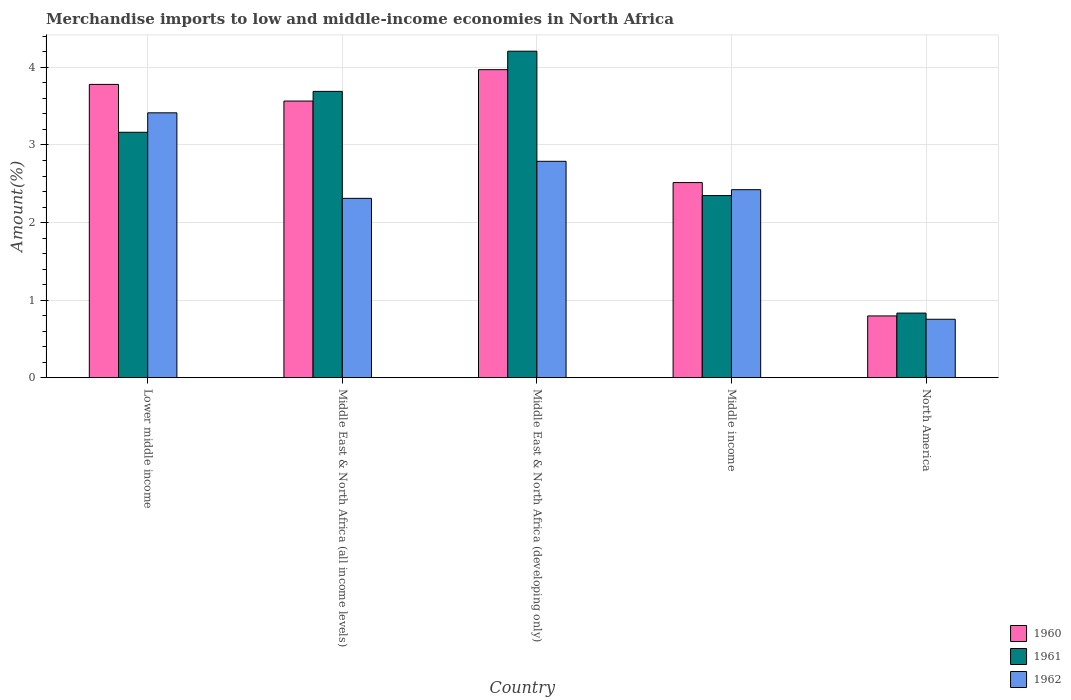How many different coloured bars are there?
Offer a very short reply. 3. How many groups of bars are there?
Your response must be concise. 5. What is the label of the 4th group of bars from the left?
Make the answer very short. Middle income. What is the percentage of amount earned from merchandise imports in 1960 in Middle East & North Africa (developing only)?
Provide a succinct answer. 3.97. Across all countries, what is the maximum percentage of amount earned from merchandise imports in 1962?
Ensure brevity in your answer.  3.41. Across all countries, what is the minimum percentage of amount earned from merchandise imports in 1961?
Make the answer very short. 0.83. In which country was the percentage of amount earned from merchandise imports in 1961 maximum?
Offer a very short reply. Middle East & North Africa (developing only). What is the total percentage of amount earned from merchandise imports in 1960 in the graph?
Your answer should be compact. 14.63. What is the difference between the percentage of amount earned from merchandise imports in 1961 in Lower middle income and that in North America?
Your answer should be very brief. 2.33. What is the difference between the percentage of amount earned from merchandise imports in 1961 in Middle income and the percentage of amount earned from merchandise imports in 1962 in Lower middle income?
Your response must be concise. -1.07. What is the average percentage of amount earned from merchandise imports in 1961 per country?
Keep it short and to the point. 2.85. What is the difference between the percentage of amount earned from merchandise imports of/in 1962 and percentage of amount earned from merchandise imports of/in 1961 in Middle East & North Africa (all income levels)?
Offer a terse response. -1.38. What is the ratio of the percentage of amount earned from merchandise imports in 1962 in Middle East & North Africa (developing only) to that in North America?
Keep it short and to the point. 3.7. Is the percentage of amount earned from merchandise imports in 1960 in Lower middle income less than that in Middle income?
Provide a succinct answer. No. What is the difference between the highest and the second highest percentage of amount earned from merchandise imports in 1961?
Offer a very short reply. -0.53. What is the difference between the highest and the lowest percentage of amount earned from merchandise imports in 1961?
Your response must be concise. 3.38. In how many countries, is the percentage of amount earned from merchandise imports in 1961 greater than the average percentage of amount earned from merchandise imports in 1961 taken over all countries?
Your response must be concise. 3. What does the 2nd bar from the right in North America represents?
Give a very brief answer. 1961. What is the difference between two consecutive major ticks on the Y-axis?
Give a very brief answer. 1. Does the graph contain any zero values?
Your response must be concise. No. How are the legend labels stacked?
Offer a very short reply. Vertical. What is the title of the graph?
Your answer should be very brief. Merchandise imports to low and middle-income economies in North Africa. Does "1962" appear as one of the legend labels in the graph?
Keep it short and to the point. Yes. What is the label or title of the Y-axis?
Make the answer very short. Amount(%). What is the Amount(%) of 1960 in Lower middle income?
Your answer should be very brief. 3.78. What is the Amount(%) of 1961 in Lower middle income?
Your answer should be very brief. 3.16. What is the Amount(%) of 1962 in Lower middle income?
Offer a very short reply. 3.41. What is the Amount(%) in 1960 in Middle East & North Africa (all income levels)?
Your answer should be very brief. 3.57. What is the Amount(%) of 1961 in Middle East & North Africa (all income levels)?
Give a very brief answer. 3.69. What is the Amount(%) of 1962 in Middle East & North Africa (all income levels)?
Give a very brief answer. 2.31. What is the Amount(%) in 1960 in Middle East & North Africa (developing only)?
Ensure brevity in your answer.  3.97. What is the Amount(%) of 1961 in Middle East & North Africa (developing only)?
Your response must be concise. 4.21. What is the Amount(%) in 1962 in Middle East & North Africa (developing only)?
Make the answer very short. 2.79. What is the Amount(%) in 1960 in Middle income?
Keep it short and to the point. 2.52. What is the Amount(%) of 1961 in Middle income?
Give a very brief answer. 2.35. What is the Amount(%) of 1962 in Middle income?
Ensure brevity in your answer.  2.42. What is the Amount(%) in 1960 in North America?
Offer a very short reply. 0.8. What is the Amount(%) of 1961 in North America?
Your answer should be compact. 0.83. What is the Amount(%) in 1962 in North America?
Offer a terse response. 0.75. Across all countries, what is the maximum Amount(%) in 1960?
Provide a short and direct response. 3.97. Across all countries, what is the maximum Amount(%) in 1961?
Offer a terse response. 4.21. Across all countries, what is the maximum Amount(%) in 1962?
Make the answer very short. 3.41. Across all countries, what is the minimum Amount(%) of 1960?
Provide a short and direct response. 0.8. Across all countries, what is the minimum Amount(%) in 1961?
Offer a very short reply. 0.83. Across all countries, what is the minimum Amount(%) of 1962?
Provide a short and direct response. 0.75. What is the total Amount(%) in 1960 in the graph?
Provide a succinct answer. 14.63. What is the total Amount(%) of 1961 in the graph?
Make the answer very short. 14.24. What is the total Amount(%) of 1962 in the graph?
Offer a terse response. 11.69. What is the difference between the Amount(%) in 1960 in Lower middle income and that in Middle East & North Africa (all income levels)?
Your answer should be very brief. 0.21. What is the difference between the Amount(%) in 1961 in Lower middle income and that in Middle East & North Africa (all income levels)?
Your response must be concise. -0.53. What is the difference between the Amount(%) in 1962 in Lower middle income and that in Middle East & North Africa (all income levels)?
Provide a succinct answer. 1.1. What is the difference between the Amount(%) of 1960 in Lower middle income and that in Middle East & North Africa (developing only)?
Give a very brief answer. -0.19. What is the difference between the Amount(%) of 1961 in Lower middle income and that in Middle East & North Africa (developing only)?
Offer a very short reply. -1.05. What is the difference between the Amount(%) of 1962 in Lower middle income and that in Middle East & North Africa (developing only)?
Ensure brevity in your answer.  0.63. What is the difference between the Amount(%) of 1960 in Lower middle income and that in Middle income?
Provide a succinct answer. 1.27. What is the difference between the Amount(%) in 1961 in Lower middle income and that in Middle income?
Offer a very short reply. 0.82. What is the difference between the Amount(%) of 1962 in Lower middle income and that in Middle income?
Give a very brief answer. 0.99. What is the difference between the Amount(%) in 1960 in Lower middle income and that in North America?
Your response must be concise. 2.98. What is the difference between the Amount(%) of 1961 in Lower middle income and that in North America?
Ensure brevity in your answer.  2.33. What is the difference between the Amount(%) of 1962 in Lower middle income and that in North America?
Offer a terse response. 2.66. What is the difference between the Amount(%) of 1960 in Middle East & North Africa (all income levels) and that in Middle East & North Africa (developing only)?
Your answer should be very brief. -0.4. What is the difference between the Amount(%) in 1961 in Middle East & North Africa (all income levels) and that in Middle East & North Africa (developing only)?
Your answer should be very brief. -0.52. What is the difference between the Amount(%) in 1962 in Middle East & North Africa (all income levels) and that in Middle East & North Africa (developing only)?
Provide a short and direct response. -0.48. What is the difference between the Amount(%) in 1960 in Middle East & North Africa (all income levels) and that in Middle income?
Provide a short and direct response. 1.05. What is the difference between the Amount(%) of 1961 in Middle East & North Africa (all income levels) and that in Middle income?
Your response must be concise. 1.34. What is the difference between the Amount(%) in 1962 in Middle East & North Africa (all income levels) and that in Middle income?
Offer a very short reply. -0.11. What is the difference between the Amount(%) in 1960 in Middle East & North Africa (all income levels) and that in North America?
Your response must be concise. 2.77. What is the difference between the Amount(%) in 1961 in Middle East & North Africa (all income levels) and that in North America?
Make the answer very short. 2.86. What is the difference between the Amount(%) of 1962 in Middle East & North Africa (all income levels) and that in North America?
Offer a very short reply. 1.56. What is the difference between the Amount(%) of 1960 in Middle East & North Africa (developing only) and that in Middle income?
Keep it short and to the point. 1.46. What is the difference between the Amount(%) of 1961 in Middle East & North Africa (developing only) and that in Middle income?
Ensure brevity in your answer.  1.86. What is the difference between the Amount(%) in 1962 in Middle East & North Africa (developing only) and that in Middle income?
Make the answer very short. 0.37. What is the difference between the Amount(%) in 1960 in Middle East & North Africa (developing only) and that in North America?
Keep it short and to the point. 3.17. What is the difference between the Amount(%) in 1961 in Middle East & North Africa (developing only) and that in North America?
Your answer should be very brief. 3.38. What is the difference between the Amount(%) in 1962 in Middle East & North Africa (developing only) and that in North America?
Keep it short and to the point. 2.04. What is the difference between the Amount(%) in 1960 in Middle income and that in North America?
Offer a terse response. 1.72. What is the difference between the Amount(%) of 1961 in Middle income and that in North America?
Provide a succinct answer. 1.52. What is the difference between the Amount(%) in 1962 in Middle income and that in North America?
Give a very brief answer. 1.67. What is the difference between the Amount(%) of 1960 in Lower middle income and the Amount(%) of 1961 in Middle East & North Africa (all income levels)?
Ensure brevity in your answer.  0.09. What is the difference between the Amount(%) of 1960 in Lower middle income and the Amount(%) of 1962 in Middle East & North Africa (all income levels)?
Keep it short and to the point. 1.47. What is the difference between the Amount(%) in 1961 in Lower middle income and the Amount(%) in 1962 in Middle East & North Africa (all income levels)?
Make the answer very short. 0.85. What is the difference between the Amount(%) of 1960 in Lower middle income and the Amount(%) of 1961 in Middle East & North Africa (developing only)?
Ensure brevity in your answer.  -0.43. What is the difference between the Amount(%) in 1960 in Lower middle income and the Amount(%) in 1962 in Middle East & North Africa (developing only)?
Keep it short and to the point. 0.99. What is the difference between the Amount(%) in 1961 in Lower middle income and the Amount(%) in 1962 in Middle East & North Africa (developing only)?
Ensure brevity in your answer.  0.37. What is the difference between the Amount(%) in 1960 in Lower middle income and the Amount(%) in 1961 in Middle income?
Provide a succinct answer. 1.43. What is the difference between the Amount(%) of 1960 in Lower middle income and the Amount(%) of 1962 in Middle income?
Offer a terse response. 1.36. What is the difference between the Amount(%) of 1961 in Lower middle income and the Amount(%) of 1962 in Middle income?
Provide a succinct answer. 0.74. What is the difference between the Amount(%) of 1960 in Lower middle income and the Amount(%) of 1961 in North America?
Provide a succinct answer. 2.95. What is the difference between the Amount(%) of 1960 in Lower middle income and the Amount(%) of 1962 in North America?
Your answer should be compact. 3.03. What is the difference between the Amount(%) in 1961 in Lower middle income and the Amount(%) in 1962 in North America?
Offer a terse response. 2.41. What is the difference between the Amount(%) of 1960 in Middle East & North Africa (all income levels) and the Amount(%) of 1961 in Middle East & North Africa (developing only)?
Provide a succinct answer. -0.64. What is the difference between the Amount(%) in 1960 in Middle East & North Africa (all income levels) and the Amount(%) in 1962 in Middle East & North Africa (developing only)?
Your answer should be very brief. 0.78. What is the difference between the Amount(%) of 1961 in Middle East & North Africa (all income levels) and the Amount(%) of 1962 in Middle East & North Africa (developing only)?
Your answer should be compact. 0.9. What is the difference between the Amount(%) in 1960 in Middle East & North Africa (all income levels) and the Amount(%) in 1961 in Middle income?
Your response must be concise. 1.22. What is the difference between the Amount(%) in 1960 in Middle East & North Africa (all income levels) and the Amount(%) in 1962 in Middle income?
Your response must be concise. 1.14. What is the difference between the Amount(%) in 1961 in Middle East & North Africa (all income levels) and the Amount(%) in 1962 in Middle income?
Provide a short and direct response. 1.27. What is the difference between the Amount(%) of 1960 in Middle East & North Africa (all income levels) and the Amount(%) of 1961 in North America?
Your response must be concise. 2.73. What is the difference between the Amount(%) in 1960 in Middle East & North Africa (all income levels) and the Amount(%) in 1962 in North America?
Offer a very short reply. 2.81. What is the difference between the Amount(%) of 1961 in Middle East & North Africa (all income levels) and the Amount(%) of 1962 in North America?
Offer a very short reply. 2.94. What is the difference between the Amount(%) of 1960 in Middle East & North Africa (developing only) and the Amount(%) of 1961 in Middle income?
Give a very brief answer. 1.62. What is the difference between the Amount(%) of 1960 in Middle East & North Africa (developing only) and the Amount(%) of 1962 in Middle income?
Ensure brevity in your answer.  1.55. What is the difference between the Amount(%) of 1961 in Middle East & North Africa (developing only) and the Amount(%) of 1962 in Middle income?
Offer a very short reply. 1.79. What is the difference between the Amount(%) in 1960 in Middle East & North Africa (developing only) and the Amount(%) in 1961 in North America?
Offer a very short reply. 3.14. What is the difference between the Amount(%) of 1960 in Middle East & North Africa (developing only) and the Amount(%) of 1962 in North America?
Ensure brevity in your answer.  3.22. What is the difference between the Amount(%) of 1961 in Middle East & North Africa (developing only) and the Amount(%) of 1962 in North America?
Your answer should be very brief. 3.46. What is the difference between the Amount(%) in 1960 in Middle income and the Amount(%) in 1961 in North America?
Provide a succinct answer. 1.68. What is the difference between the Amount(%) of 1960 in Middle income and the Amount(%) of 1962 in North America?
Offer a terse response. 1.76. What is the difference between the Amount(%) in 1961 in Middle income and the Amount(%) in 1962 in North America?
Ensure brevity in your answer.  1.59. What is the average Amount(%) of 1960 per country?
Keep it short and to the point. 2.93. What is the average Amount(%) in 1961 per country?
Give a very brief answer. 2.85. What is the average Amount(%) in 1962 per country?
Keep it short and to the point. 2.34. What is the difference between the Amount(%) in 1960 and Amount(%) in 1961 in Lower middle income?
Offer a terse response. 0.62. What is the difference between the Amount(%) in 1960 and Amount(%) in 1962 in Lower middle income?
Provide a succinct answer. 0.37. What is the difference between the Amount(%) in 1961 and Amount(%) in 1962 in Lower middle income?
Offer a terse response. -0.25. What is the difference between the Amount(%) in 1960 and Amount(%) in 1961 in Middle East & North Africa (all income levels)?
Your answer should be compact. -0.12. What is the difference between the Amount(%) in 1960 and Amount(%) in 1962 in Middle East & North Africa (all income levels)?
Provide a succinct answer. 1.25. What is the difference between the Amount(%) in 1961 and Amount(%) in 1962 in Middle East & North Africa (all income levels)?
Your response must be concise. 1.38. What is the difference between the Amount(%) in 1960 and Amount(%) in 1961 in Middle East & North Africa (developing only)?
Your response must be concise. -0.24. What is the difference between the Amount(%) in 1960 and Amount(%) in 1962 in Middle East & North Africa (developing only)?
Keep it short and to the point. 1.18. What is the difference between the Amount(%) in 1961 and Amount(%) in 1962 in Middle East & North Africa (developing only)?
Your answer should be very brief. 1.42. What is the difference between the Amount(%) of 1960 and Amount(%) of 1961 in Middle income?
Your answer should be very brief. 0.17. What is the difference between the Amount(%) in 1960 and Amount(%) in 1962 in Middle income?
Your answer should be very brief. 0.09. What is the difference between the Amount(%) in 1961 and Amount(%) in 1962 in Middle income?
Ensure brevity in your answer.  -0.08. What is the difference between the Amount(%) in 1960 and Amount(%) in 1961 in North America?
Keep it short and to the point. -0.04. What is the difference between the Amount(%) in 1960 and Amount(%) in 1962 in North America?
Your answer should be compact. 0.04. What is the difference between the Amount(%) in 1961 and Amount(%) in 1962 in North America?
Offer a terse response. 0.08. What is the ratio of the Amount(%) in 1960 in Lower middle income to that in Middle East & North Africa (all income levels)?
Your response must be concise. 1.06. What is the ratio of the Amount(%) of 1961 in Lower middle income to that in Middle East & North Africa (all income levels)?
Your answer should be very brief. 0.86. What is the ratio of the Amount(%) of 1962 in Lower middle income to that in Middle East & North Africa (all income levels)?
Provide a short and direct response. 1.48. What is the ratio of the Amount(%) of 1960 in Lower middle income to that in Middle East & North Africa (developing only)?
Offer a very short reply. 0.95. What is the ratio of the Amount(%) of 1961 in Lower middle income to that in Middle East & North Africa (developing only)?
Give a very brief answer. 0.75. What is the ratio of the Amount(%) of 1962 in Lower middle income to that in Middle East & North Africa (developing only)?
Keep it short and to the point. 1.22. What is the ratio of the Amount(%) of 1960 in Lower middle income to that in Middle income?
Provide a succinct answer. 1.5. What is the ratio of the Amount(%) in 1961 in Lower middle income to that in Middle income?
Your answer should be very brief. 1.35. What is the ratio of the Amount(%) of 1962 in Lower middle income to that in Middle income?
Give a very brief answer. 1.41. What is the ratio of the Amount(%) in 1960 in Lower middle income to that in North America?
Your answer should be compact. 4.75. What is the ratio of the Amount(%) of 1961 in Lower middle income to that in North America?
Offer a terse response. 3.8. What is the ratio of the Amount(%) in 1962 in Lower middle income to that in North America?
Ensure brevity in your answer.  4.53. What is the ratio of the Amount(%) in 1960 in Middle East & North Africa (all income levels) to that in Middle East & North Africa (developing only)?
Give a very brief answer. 0.9. What is the ratio of the Amount(%) of 1961 in Middle East & North Africa (all income levels) to that in Middle East & North Africa (developing only)?
Your answer should be compact. 0.88. What is the ratio of the Amount(%) in 1962 in Middle East & North Africa (all income levels) to that in Middle East & North Africa (developing only)?
Your answer should be very brief. 0.83. What is the ratio of the Amount(%) in 1960 in Middle East & North Africa (all income levels) to that in Middle income?
Offer a very short reply. 1.42. What is the ratio of the Amount(%) of 1961 in Middle East & North Africa (all income levels) to that in Middle income?
Provide a succinct answer. 1.57. What is the ratio of the Amount(%) in 1962 in Middle East & North Africa (all income levels) to that in Middle income?
Offer a very short reply. 0.95. What is the ratio of the Amount(%) in 1960 in Middle East & North Africa (all income levels) to that in North America?
Provide a succinct answer. 4.48. What is the ratio of the Amount(%) in 1961 in Middle East & North Africa (all income levels) to that in North America?
Your response must be concise. 4.43. What is the ratio of the Amount(%) of 1962 in Middle East & North Africa (all income levels) to that in North America?
Your answer should be compact. 3.07. What is the ratio of the Amount(%) in 1960 in Middle East & North Africa (developing only) to that in Middle income?
Ensure brevity in your answer.  1.58. What is the ratio of the Amount(%) of 1961 in Middle East & North Africa (developing only) to that in Middle income?
Your response must be concise. 1.79. What is the ratio of the Amount(%) of 1962 in Middle East & North Africa (developing only) to that in Middle income?
Provide a succinct answer. 1.15. What is the ratio of the Amount(%) of 1960 in Middle East & North Africa (developing only) to that in North America?
Make the answer very short. 4.99. What is the ratio of the Amount(%) in 1961 in Middle East & North Africa (developing only) to that in North America?
Keep it short and to the point. 5.06. What is the ratio of the Amount(%) of 1962 in Middle East & North Africa (developing only) to that in North America?
Your response must be concise. 3.7. What is the ratio of the Amount(%) of 1960 in Middle income to that in North America?
Your answer should be very brief. 3.16. What is the ratio of the Amount(%) of 1961 in Middle income to that in North America?
Keep it short and to the point. 2.82. What is the ratio of the Amount(%) of 1962 in Middle income to that in North America?
Provide a short and direct response. 3.22. What is the difference between the highest and the second highest Amount(%) in 1960?
Give a very brief answer. 0.19. What is the difference between the highest and the second highest Amount(%) of 1961?
Offer a very short reply. 0.52. What is the difference between the highest and the second highest Amount(%) of 1962?
Your response must be concise. 0.63. What is the difference between the highest and the lowest Amount(%) in 1960?
Give a very brief answer. 3.17. What is the difference between the highest and the lowest Amount(%) in 1961?
Your response must be concise. 3.38. What is the difference between the highest and the lowest Amount(%) in 1962?
Give a very brief answer. 2.66. 